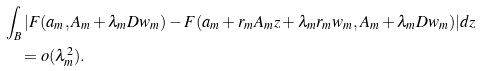Convert formula to latex. <formula><loc_0><loc_0><loc_500><loc_500>& \int _ { B } | F ( a _ { m } , A _ { m } + \lambda _ { m } D w _ { m } ) - F ( a _ { m } + r _ { m } A _ { m } z + \lambda _ { m } r _ { m } w _ { m } , A _ { m } + \lambda _ { m } D w _ { m } ) | d z \\ & \quad = o ( \lambda _ { m } ^ { 2 } ) .</formula> 